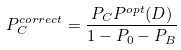Convert formula to latex. <formula><loc_0><loc_0><loc_500><loc_500>P _ { C } ^ { c o r r e c t } = \frac { P _ { C } P ^ { o p t } ( D ) } { 1 - P _ { 0 } - P _ { B } }</formula> 